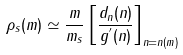Convert formula to latex. <formula><loc_0><loc_0><loc_500><loc_500>\rho _ { s } ( m ) \simeq \frac { m } { m _ { s } } \left [ \frac { d _ { n } ( n ) } { g ^ { ^ { \prime } } ( n ) } \right ] _ { n = n ( m ) }</formula> 